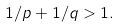Convert formula to latex. <formula><loc_0><loc_0><loc_500><loc_500>1 / p + 1 / q > 1 .</formula> 